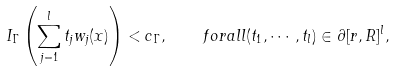<formula> <loc_0><loc_0><loc_500><loc_500>I _ { \Gamma } \left ( \sum _ { j = 1 } ^ { l } t _ { j } w _ { j } ( x ) \right ) < c _ { \Gamma } , \quad f o r a l l ( t _ { 1 } , \cdots , t _ { l } ) \in \partial [ r , R ] ^ { l } ,</formula> 